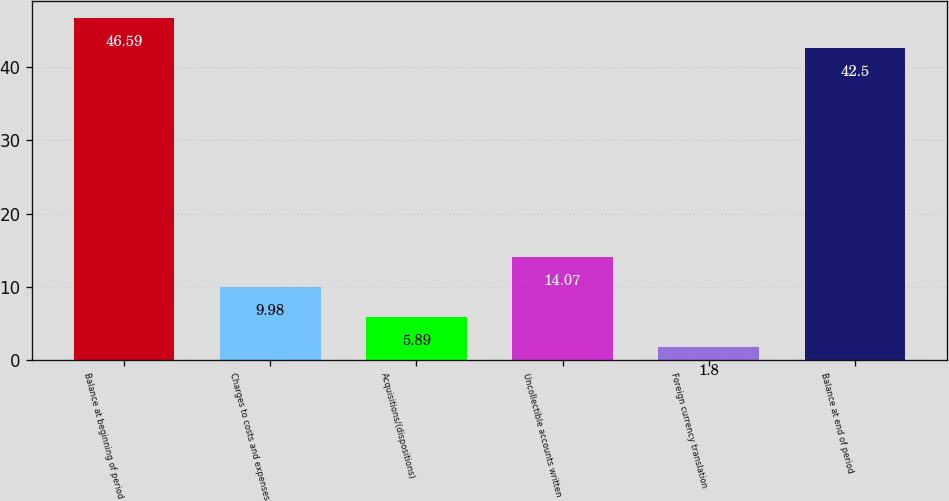Convert chart to OTSL. <chart><loc_0><loc_0><loc_500><loc_500><bar_chart><fcel>Balance at beginning of period<fcel>Charges to costs and expenses<fcel>Acquisitions/(dispositions)<fcel>Uncollectible accounts written<fcel>Foreign currency translation<fcel>Balance at end of period<nl><fcel>46.59<fcel>9.98<fcel>5.89<fcel>14.07<fcel>1.8<fcel>42.5<nl></chart> 